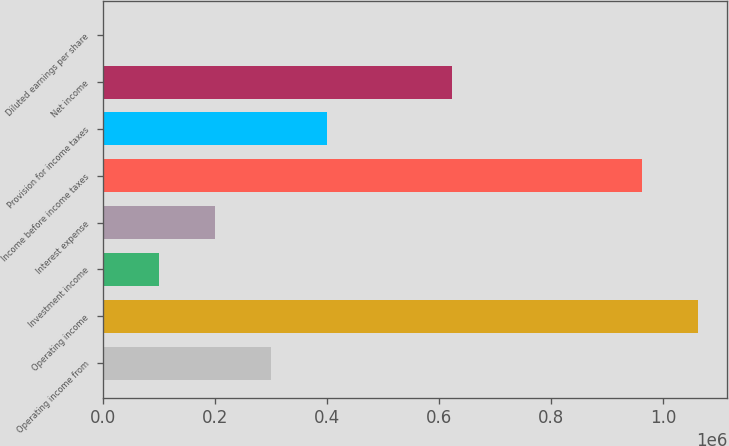Convert chart to OTSL. <chart><loc_0><loc_0><loc_500><loc_500><bar_chart><fcel>Operating income from<fcel>Operating income<fcel>Investment income<fcel>Interest expense<fcel>Income before income taxes<fcel>Provision for income taxes<fcel>Net income<fcel>Diluted earnings per share<nl><fcel>300055<fcel>1.06153e+06<fcel>100020<fcel>200037<fcel>961512<fcel>400072<fcel>623925<fcel>2.72<nl></chart> 